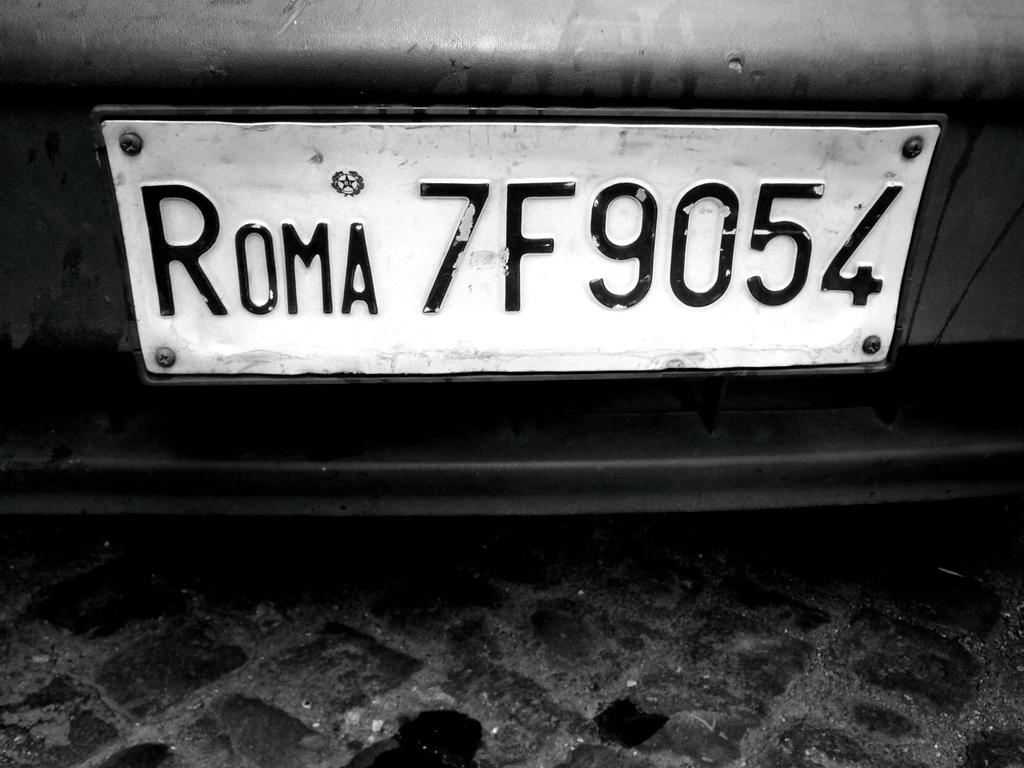<image>
Present a compact description of the photo's key features. An Italian license plate in black and white that says ROMA 7F9054. 